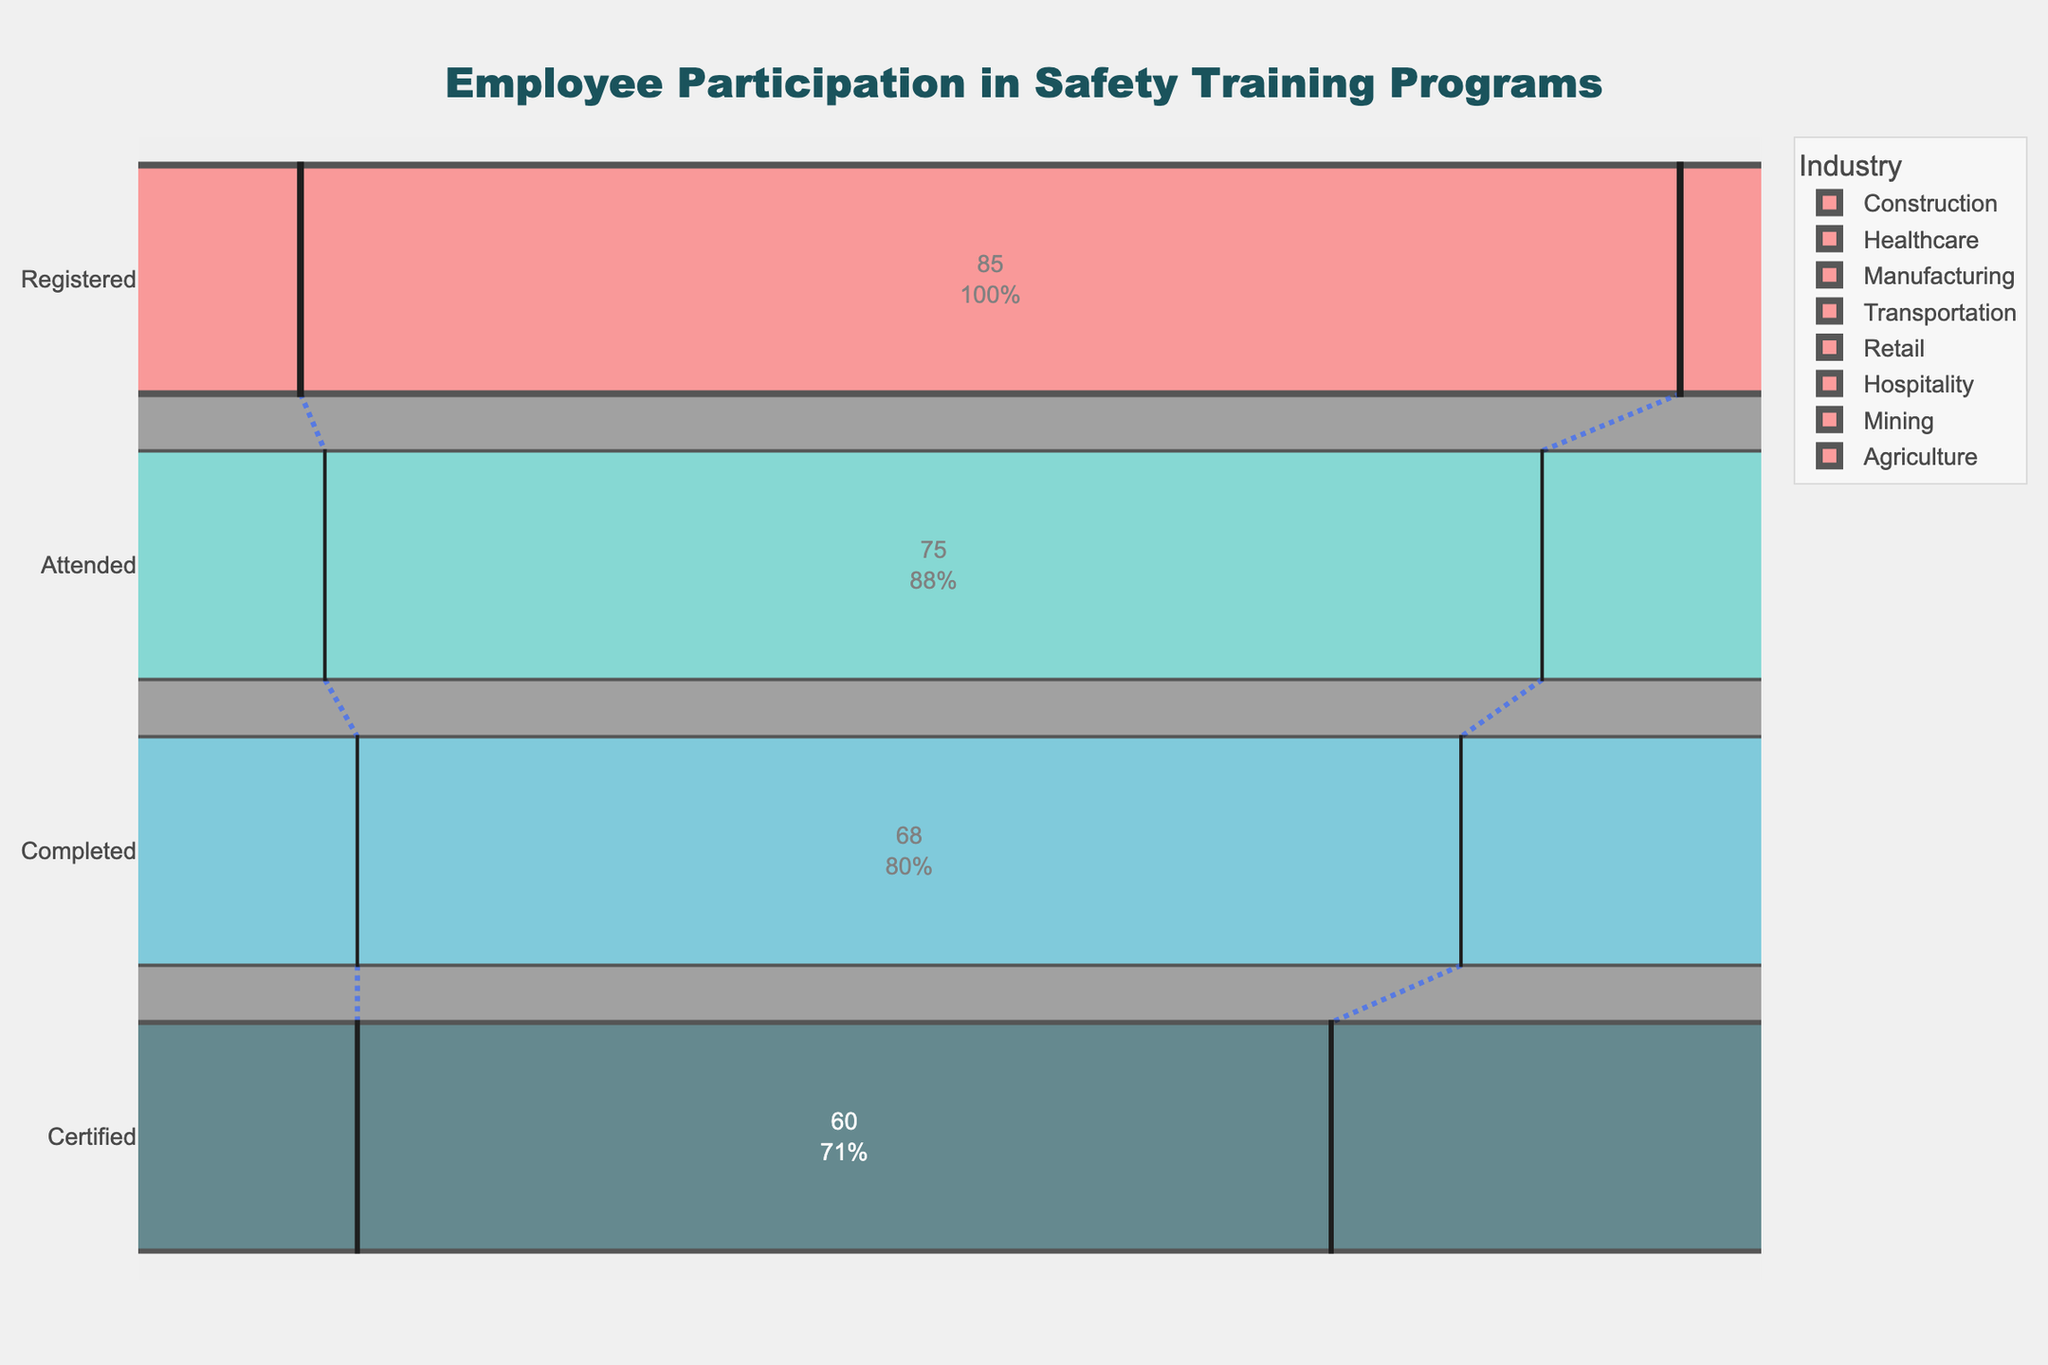What's the title of the figure? The title is found at the top center of the figure, indicating what the chart is about.
Answer: "Employee Participation in Safety Training Programs" Which industry had the highest number of employees certified? From the figure, the industry with the highest bar at the "Certified" stage represents the highest number.
Answer: Mining How many employees from the Healthcare industry completed the training? Look at the "Completed" stage from the Healthcare industry funnel to find this number.
Answer: 85 What's the difference between the number of employees who attended the training in Healthcare and Agriculture? The "Attended" stage number for Healthcare is subtracted from the same stage number for Agriculture.
Answer: 88 - 70 = 18 Which two industries have the closest number of employees certified? Compare the "Certified" stage numbers and find the two closest ones. Hospitality and Retail have values of 58 and 60 respectively.
Answer: Hospitality and Retail How does the registration rate of the Construction industry compare to the Healthcare industry? Compare the "Registered" stage values for Construction and Healthcare.
Answer: Construction has 95, and Healthcare has 92, so Construction is higher What proportion of registered employees in Transportation completed the training? Divide the "Completed" number by the "Registered" number for Transportation and express it as a percentage.
Answer: (75 / 88) * 100 ≈ 85.23% What's the average number of employees certified across all industries? Sum all values from the "Certified" stage and divide by the number of industries. (70 + 80 + 72 + 68 + 60 + 58 + 90 + 55) / 8 = 69.125
Answer: 69 (rounded) Which stages show the largest drop in employee numbers for the Mining industry? Compare the differences between consecutive stages for Mining and identify the largest drop.
Answer: The drop from "Registered" (98) to "Attended" (95) is 3, "Attended" to "Completed" is 3, and "Completed" to "Certified" is 2; hence, "Registered" to "Attended" is the largest drop What's the participation rate trend from registration to certification in the Retail industry? Analyse the values for each stage in Retail from "Registered" to "Certified" and see if the numbers increase or decrease.
Answer: The trend is a steady decrease: Registered (85), Attended (75), Completed (68), Certified (60) 